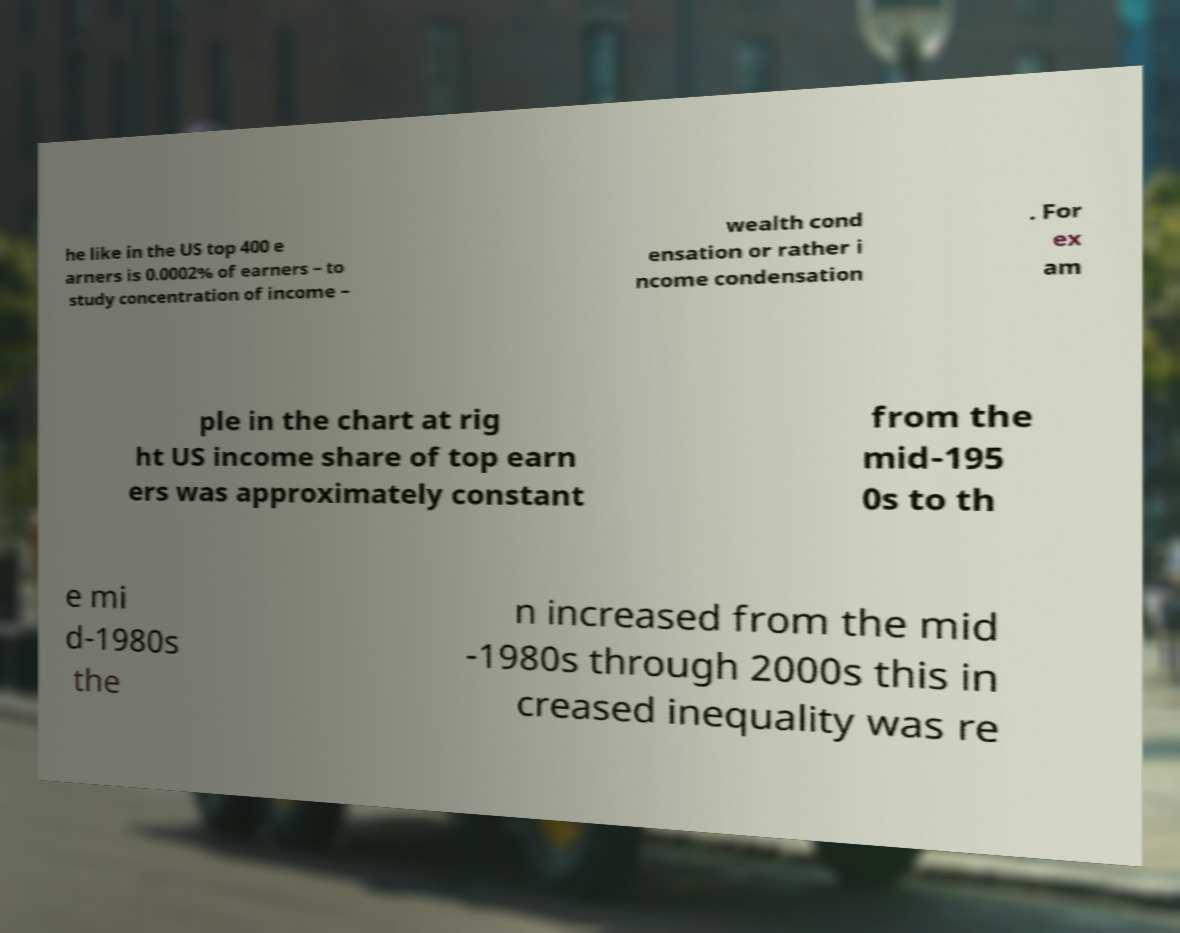Could you extract and type out the text from this image? he like in the US top 400 e arners is 0.0002% of earners – to study concentration of income – wealth cond ensation or rather i ncome condensation . For ex am ple in the chart at rig ht US income share of top earn ers was approximately constant from the mid-195 0s to th e mi d-1980s the n increased from the mid -1980s through 2000s this in creased inequality was re 